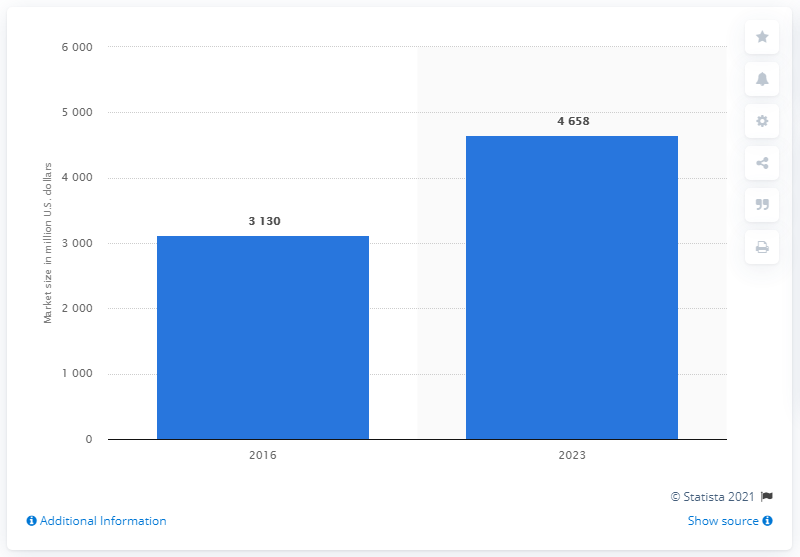How much is the market expected to grow by 2023? According to the bar chart, the market size is anticipated to grow to approximately 4.658 trillion U.S. dollars by 2023. 